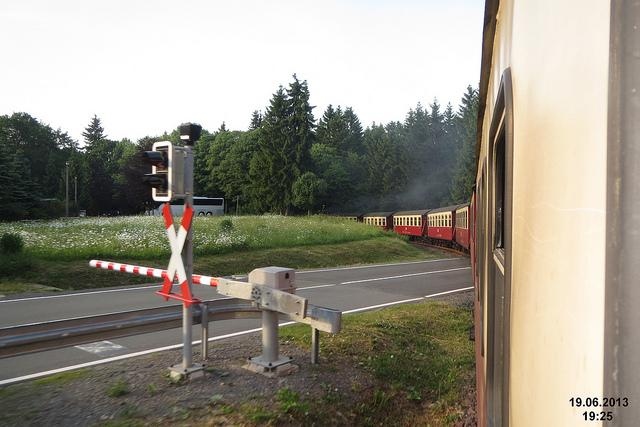What color is the area of the train car around the window?

Choices:
A) orange
B) cream
C) white
D) pink cream 